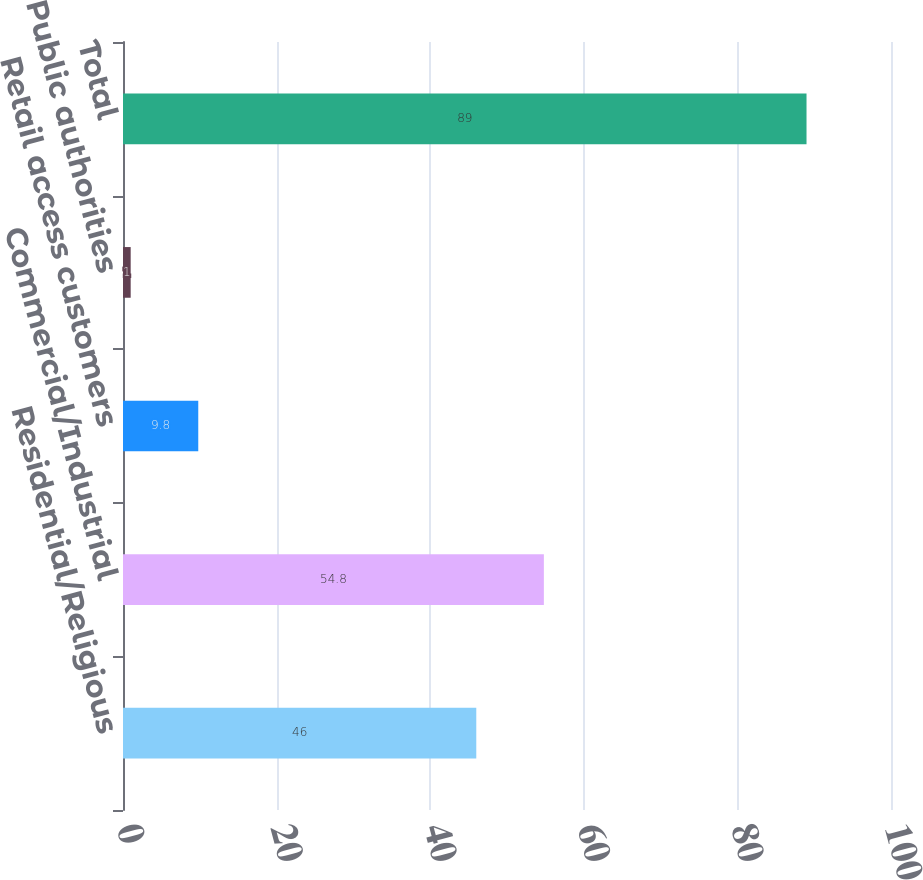Convert chart. <chart><loc_0><loc_0><loc_500><loc_500><bar_chart><fcel>Residential/Religious<fcel>Commercial/Industrial<fcel>Retail access customers<fcel>Public authorities<fcel>Total<nl><fcel>46<fcel>54.8<fcel>9.8<fcel>1<fcel>89<nl></chart> 